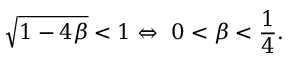Convert formula to latex. <formula><loc_0><loc_0><loc_500><loc_500>\sqrt { 1 - 4 \beta } < 1 \Leftrightarrow \ 0 < \beta < { \frac { 1 } { 4 } } .</formula> 